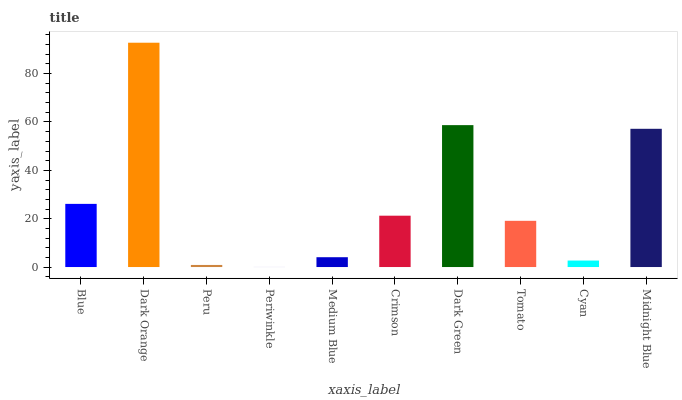Is Peru the minimum?
Answer yes or no. No. Is Peru the maximum?
Answer yes or no. No. Is Dark Orange greater than Peru?
Answer yes or no. Yes. Is Peru less than Dark Orange?
Answer yes or no. Yes. Is Peru greater than Dark Orange?
Answer yes or no. No. Is Dark Orange less than Peru?
Answer yes or no. No. Is Crimson the high median?
Answer yes or no. Yes. Is Tomato the low median?
Answer yes or no. Yes. Is Dark Orange the high median?
Answer yes or no. No. Is Medium Blue the low median?
Answer yes or no. No. 